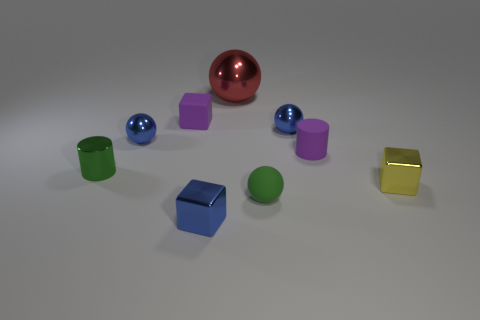Subtract all small purple rubber blocks. How many blocks are left? 2 Subtract all yellow blocks. How many blue balls are left? 2 Subtract all red balls. How many balls are left? 3 Add 1 large brown metal spheres. How many objects exist? 10 Subtract all cylinders. How many objects are left? 7 Subtract all yellow spheres. Subtract all yellow cylinders. How many spheres are left? 4 Subtract all small matte cylinders. Subtract all large green cubes. How many objects are left? 8 Add 2 purple rubber things. How many purple rubber things are left? 4 Add 2 blue metallic things. How many blue metallic things exist? 5 Subtract 0 blue cylinders. How many objects are left? 9 